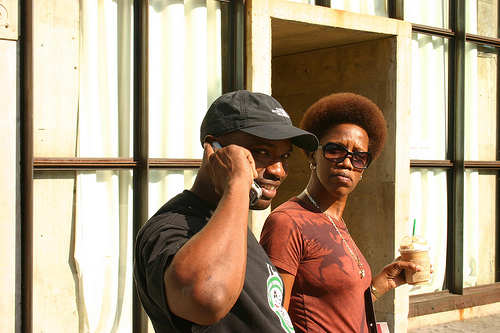What are the people in the image doing? The man is talking on his cell phone, engaged in a conversation, while the woman is standing beside him, holding what appears to be an iced coffee, looking intently in the direction of the camera. 